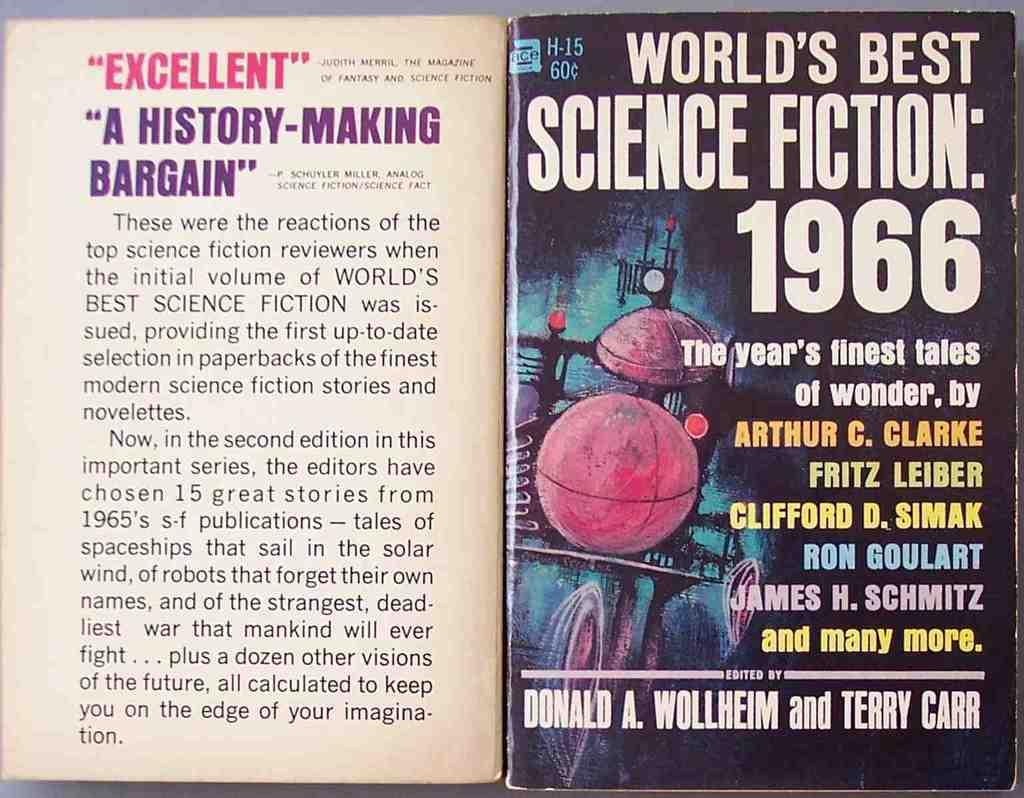<image>
Summarize the visual content of the image. Front and back cover of paper back vintage book for World's Best Science Fiction 1966 book with illustrated cover. 